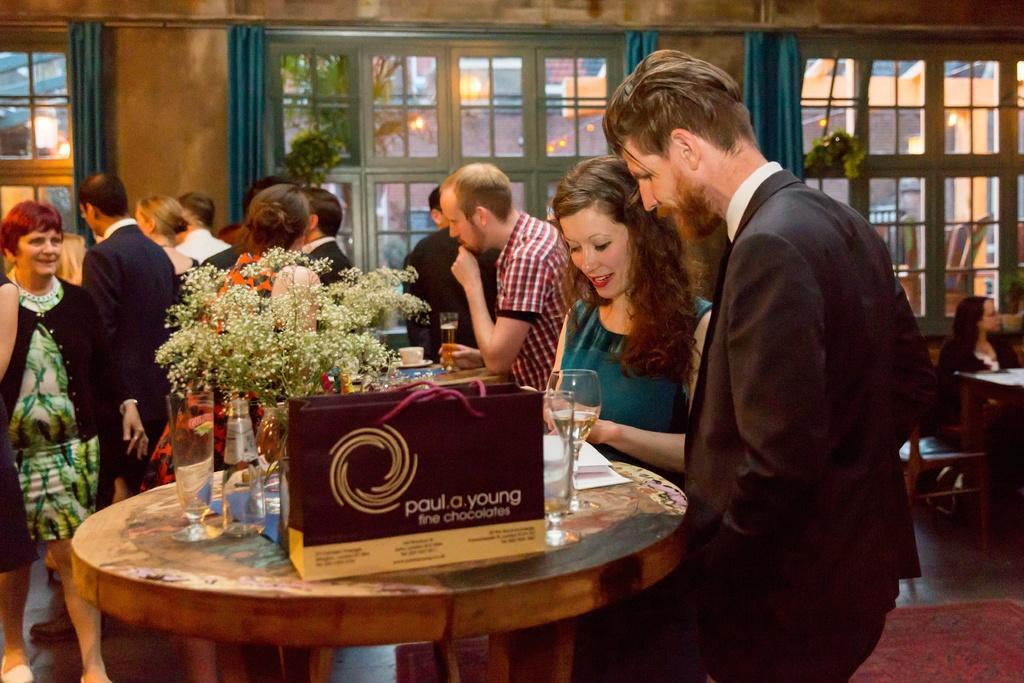In one or two sentences, can you explain what this image depicts? In the picture we can see few people are sitting on the chairs near the table, on the first table we can see a man and woman standing on the table we can see a bag which is red in color and near to it there is a glass, some papers, and a plant which is decorated on table and some bottles, in the background we can see a windows, to the wall and there is a curtain which is blue in color. 